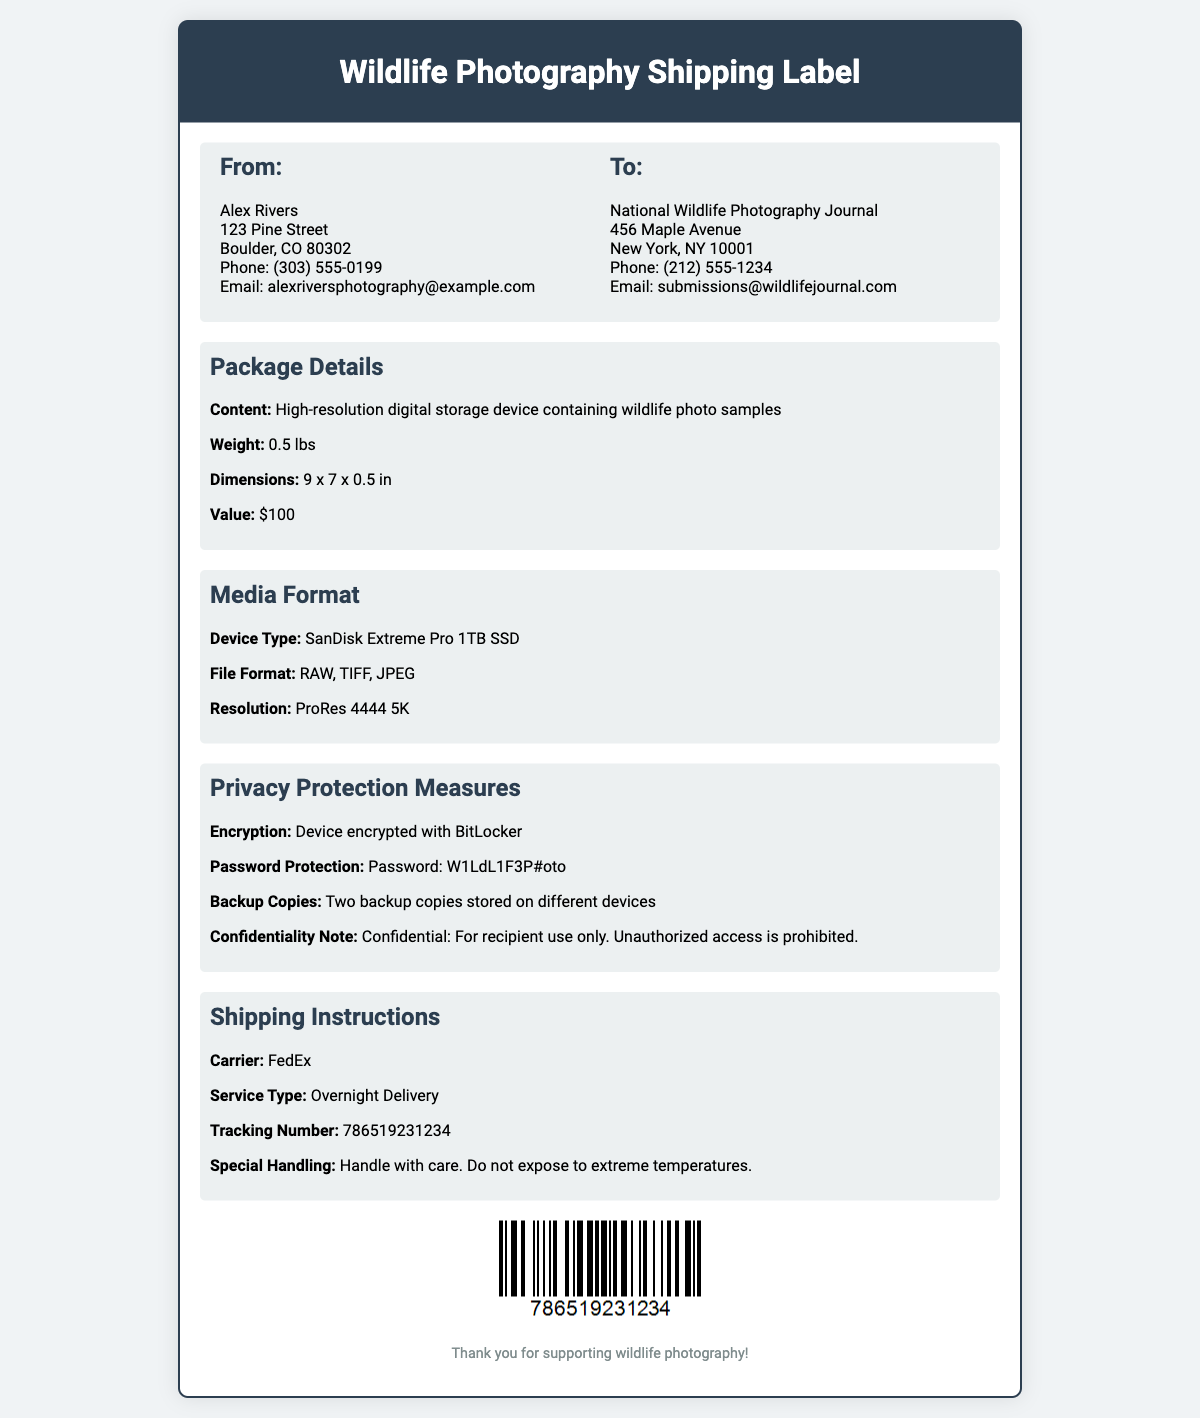what is the sender's name? The sender's name, as stated in the document, is Alex Rivers.
Answer: Alex Rivers what is the recipient's email address? The recipient's email address is listed as submissions@wildlifejournal.com.
Answer: submissions@wildlifejournal.com what device type is used for the media? The document specifies the device type as SanDisk Extreme Pro 1TB SSD.
Answer: SanDisk Extreme Pro 1TB SSD what is the declared value of the package? The declared value of the package is mentioned in the document as $100.
Answer: $100 what type of encryption is used on the device? The type of encryption utilized on the device is specified as BitLocker.
Answer: BitLocker what are the file formats included in the package? The document lists the file formats as RAW, TIFF, and JPEG.
Answer: RAW, TIFF, JPEG how many backup copies are stored? The document mentions that there are two backup copies stored.
Answer: Two what shipping service is used? The shipping service mentioned for this package is FedEx.
Answer: FedEx what is the tracking number for the shipment? The tracking number provided in the document is 786519231234.
Answer: 786519231234 